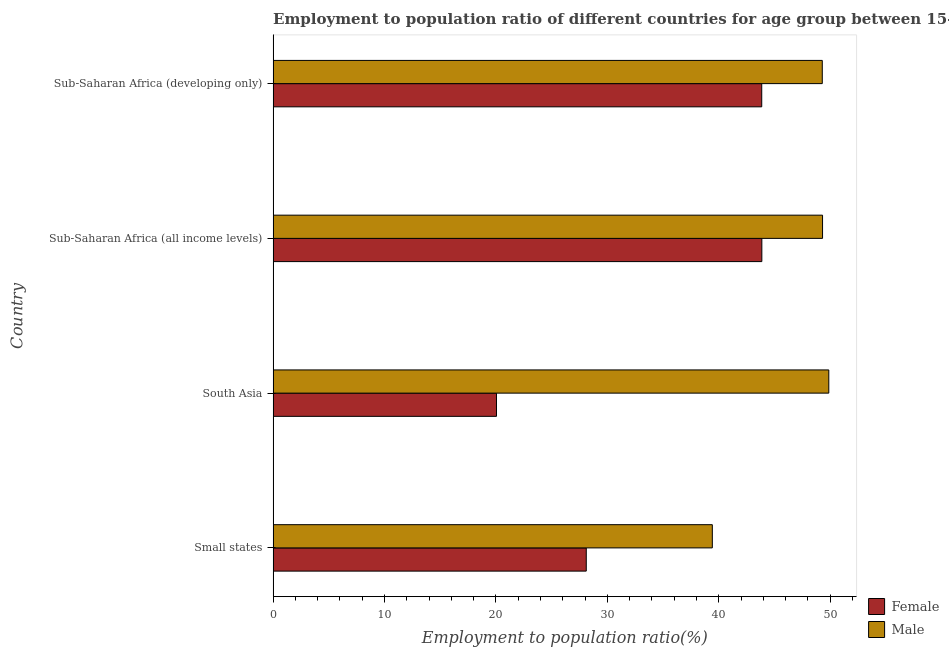How many different coloured bars are there?
Provide a short and direct response. 2. How many groups of bars are there?
Ensure brevity in your answer.  4. What is the label of the 4th group of bars from the top?
Your answer should be compact. Small states. What is the employment to population ratio(male) in Sub-Saharan Africa (all income levels)?
Keep it short and to the point. 49.32. Across all countries, what is the maximum employment to population ratio(female)?
Ensure brevity in your answer.  43.87. Across all countries, what is the minimum employment to population ratio(male)?
Provide a short and direct response. 39.42. In which country was the employment to population ratio(female) minimum?
Your answer should be compact. South Asia. What is the total employment to population ratio(male) in the graph?
Your response must be concise. 187.91. What is the difference between the employment to population ratio(male) in Small states and that in Sub-Saharan Africa (developing only)?
Your answer should be compact. -9.87. What is the difference between the employment to population ratio(male) in South Asia and the employment to population ratio(female) in Sub-Saharan Africa (developing only)?
Your answer should be compact. 6.02. What is the average employment to population ratio(female) per country?
Offer a very short reply. 33.97. What is the difference between the employment to population ratio(male) and employment to population ratio(female) in Sub-Saharan Africa (developing only)?
Ensure brevity in your answer.  5.43. In how many countries, is the employment to population ratio(female) greater than 48 %?
Provide a short and direct response. 0. What is the difference between the highest and the second highest employment to population ratio(male)?
Provide a succinct answer. 0.56. What is the difference between the highest and the lowest employment to population ratio(male)?
Make the answer very short. 10.45. In how many countries, is the employment to population ratio(female) greater than the average employment to population ratio(female) taken over all countries?
Your response must be concise. 2. What does the 1st bar from the top in Sub-Saharan Africa (all income levels) represents?
Offer a very short reply. Male. How many bars are there?
Your answer should be very brief. 8. Are all the bars in the graph horizontal?
Give a very brief answer. Yes. What is the difference between two consecutive major ticks on the X-axis?
Offer a very short reply. 10. Are the values on the major ticks of X-axis written in scientific E-notation?
Make the answer very short. No. Does the graph contain any zero values?
Provide a short and direct response. No. Where does the legend appear in the graph?
Ensure brevity in your answer.  Bottom right. How many legend labels are there?
Offer a very short reply. 2. How are the legend labels stacked?
Make the answer very short. Vertical. What is the title of the graph?
Give a very brief answer. Employment to population ratio of different countries for age group between 15-24 years. What is the label or title of the X-axis?
Provide a succinct answer. Employment to population ratio(%). What is the Employment to population ratio(%) in Female in Small states?
Keep it short and to the point. 28.11. What is the Employment to population ratio(%) of Male in Small states?
Provide a succinct answer. 39.42. What is the Employment to population ratio(%) in Female in South Asia?
Your answer should be compact. 20.05. What is the Employment to population ratio(%) of Male in South Asia?
Your answer should be compact. 49.88. What is the Employment to population ratio(%) of Female in Sub-Saharan Africa (all income levels)?
Your answer should be compact. 43.87. What is the Employment to population ratio(%) in Male in Sub-Saharan Africa (all income levels)?
Your answer should be very brief. 49.32. What is the Employment to population ratio(%) of Female in Sub-Saharan Africa (developing only)?
Make the answer very short. 43.86. What is the Employment to population ratio(%) in Male in Sub-Saharan Africa (developing only)?
Provide a short and direct response. 49.29. Across all countries, what is the maximum Employment to population ratio(%) of Female?
Your answer should be compact. 43.87. Across all countries, what is the maximum Employment to population ratio(%) of Male?
Provide a succinct answer. 49.88. Across all countries, what is the minimum Employment to population ratio(%) in Female?
Make the answer very short. 20.05. Across all countries, what is the minimum Employment to population ratio(%) in Male?
Provide a succinct answer. 39.42. What is the total Employment to population ratio(%) of Female in the graph?
Your response must be concise. 135.88. What is the total Employment to population ratio(%) in Male in the graph?
Give a very brief answer. 187.91. What is the difference between the Employment to population ratio(%) in Female in Small states and that in South Asia?
Provide a short and direct response. 8.06. What is the difference between the Employment to population ratio(%) of Male in Small states and that in South Asia?
Your response must be concise. -10.45. What is the difference between the Employment to population ratio(%) in Female in Small states and that in Sub-Saharan Africa (all income levels)?
Make the answer very short. -15.76. What is the difference between the Employment to population ratio(%) of Male in Small states and that in Sub-Saharan Africa (all income levels)?
Provide a short and direct response. -9.89. What is the difference between the Employment to population ratio(%) in Female in Small states and that in Sub-Saharan Africa (developing only)?
Offer a very short reply. -15.75. What is the difference between the Employment to population ratio(%) of Male in Small states and that in Sub-Saharan Africa (developing only)?
Give a very brief answer. -9.87. What is the difference between the Employment to population ratio(%) of Female in South Asia and that in Sub-Saharan Africa (all income levels)?
Your answer should be compact. -23.82. What is the difference between the Employment to population ratio(%) in Male in South Asia and that in Sub-Saharan Africa (all income levels)?
Provide a short and direct response. 0.56. What is the difference between the Employment to population ratio(%) of Female in South Asia and that in Sub-Saharan Africa (developing only)?
Keep it short and to the point. -23.81. What is the difference between the Employment to population ratio(%) of Male in South Asia and that in Sub-Saharan Africa (developing only)?
Offer a very short reply. 0.59. What is the difference between the Employment to population ratio(%) in Female in Sub-Saharan Africa (all income levels) and that in Sub-Saharan Africa (developing only)?
Offer a terse response. 0.01. What is the difference between the Employment to population ratio(%) in Male in Sub-Saharan Africa (all income levels) and that in Sub-Saharan Africa (developing only)?
Make the answer very short. 0.02. What is the difference between the Employment to population ratio(%) of Female in Small states and the Employment to population ratio(%) of Male in South Asia?
Provide a short and direct response. -21.77. What is the difference between the Employment to population ratio(%) of Female in Small states and the Employment to population ratio(%) of Male in Sub-Saharan Africa (all income levels)?
Offer a very short reply. -21.21. What is the difference between the Employment to population ratio(%) in Female in Small states and the Employment to population ratio(%) in Male in Sub-Saharan Africa (developing only)?
Your answer should be very brief. -21.18. What is the difference between the Employment to population ratio(%) in Female in South Asia and the Employment to population ratio(%) in Male in Sub-Saharan Africa (all income levels)?
Give a very brief answer. -29.27. What is the difference between the Employment to population ratio(%) in Female in South Asia and the Employment to population ratio(%) in Male in Sub-Saharan Africa (developing only)?
Offer a terse response. -29.24. What is the difference between the Employment to population ratio(%) of Female in Sub-Saharan Africa (all income levels) and the Employment to population ratio(%) of Male in Sub-Saharan Africa (developing only)?
Ensure brevity in your answer.  -5.42. What is the average Employment to population ratio(%) in Female per country?
Offer a very short reply. 33.97. What is the average Employment to population ratio(%) in Male per country?
Provide a succinct answer. 46.98. What is the difference between the Employment to population ratio(%) in Female and Employment to population ratio(%) in Male in Small states?
Provide a succinct answer. -11.31. What is the difference between the Employment to population ratio(%) of Female and Employment to population ratio(%) of Male in South Asia?
Ensure brevity in your answer.  -29.83. What is the difference between the Employment to population ratio(%) of Female and Employment to population ratio(%) of Male in Sub-Saharan Africa (all income levels)?
Give a very brief answer. -5.45. What is the difference between the Employment to population ratio(%) of Female and Employment to population ratio(%) of Male in Sub-Saharan Africa (developing only)?
Make the answer very short. -5.43. What is the ratio of the Employment to population ratio(%) of Female in Small states to that in South Asia?
Give a very brief answer. 1.4. What is the ratio of the Employment to population ratio(%) of Male in Small states to that in South Asia?
Offer a terse response. 0.79. What is the ratio of the Employment to population ratio(%) in Female in Small states to that in Sub-Saharan Africa (all income levels)?
Your answer should be very brief. 0.64. What is the ratio of the Employment to population ratio(%) in Male in Small states to that in Sub-Saharan Africa (all income levels)?
Offer a very short reply. 0.8. What is the ratio of the Employment to population ratio(%) of Female in Small states to that in Sub-Saharan Africa (developing only)?
Your answer should be compact. 0.64. What is the ratio of the Employment to population ratio(%) of Male in Small states to that in Sub-Saharan Africa (developing only)?
Your answer should be very brief. 0.8. What is the ratio of the Employment to population ratio(%) of Female in South Asia to that in Sub-Saharan Africa (all income levels)?
Ensure brevity in your answer.  0.46. What is the ratio of the Employment to population ratio(%) of Male in South Asia to that in Sub-Saharan Africa (all income levels)?
Offer a terse response. 1.01. What is the ratio of the Employment to population ratio(%) of Female in South Asia to that in Sub-Saharan Africa (developing only)?
Make the answer very short. 0.46. What is the ratio of the Employment to population ratio(%) in Male in South Asia to that in Sub-Saharan Africa (developing only)?
Give a very brief answer. 1.01. What is the ratio of the Employment to population ratio(%) in Male in Sub-Saharan Africa (all income levels) to that in Sub-Saharan Africa (developing only)?
Give a very brief answer. 1. What is the difference between the highest and the second highest Employment to population ratio(%) in Female?
Your answer should be compact. 0.01. What is the difference between the highest and the second highest Employment to population ratio(%) in Male?
Provide a succinct answer. 0.56. What is the difference between the highest and the lowest Employment to population ratio(%) of Female?
Provide a short and direct response. 23.82. What is the difference between the highest and the lowest Employment to population ratio(%) of Male?
Your answer should be compact. 10.45. 